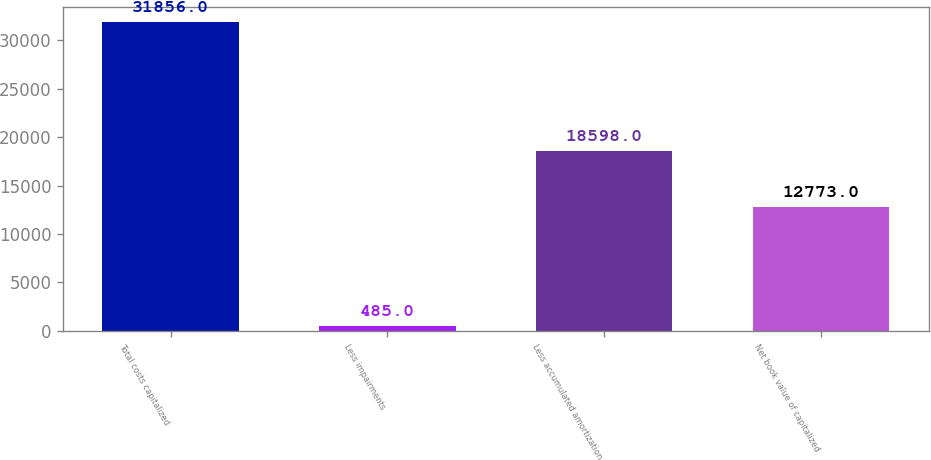<chart> <loc_0><loc_0><loc_500><loc_500><bar_chart><fcel>Total costs capitalized<fcel>Less impairments<fcel>Less accumulated amortization<fcel>Net book value of capitalized<nl><fcel>31856<fcel>485<fcel>18598<fcel>12773<nl></chart> 